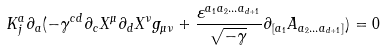<formula> <loc_0><loc_0><loc_500><loc_500>K _ { j } ^ { a } \partial _ { a } ( - \gamma ^ { c d } \partial _ { c } X ^ { \mu } \partial _ { d } X ^ { \nu } g _ { \mu \nu } + \frac { \varepsilon ^ { a _ { 1 } a _ { 2 } \dots a _ { d + 1 } } } { \sqrt { - \gamma } } \partial _ { [ a _ { 1 } } A _ { a _ { 2 } \dots a _ { d + 1 } ] } ) = 0</formula> 